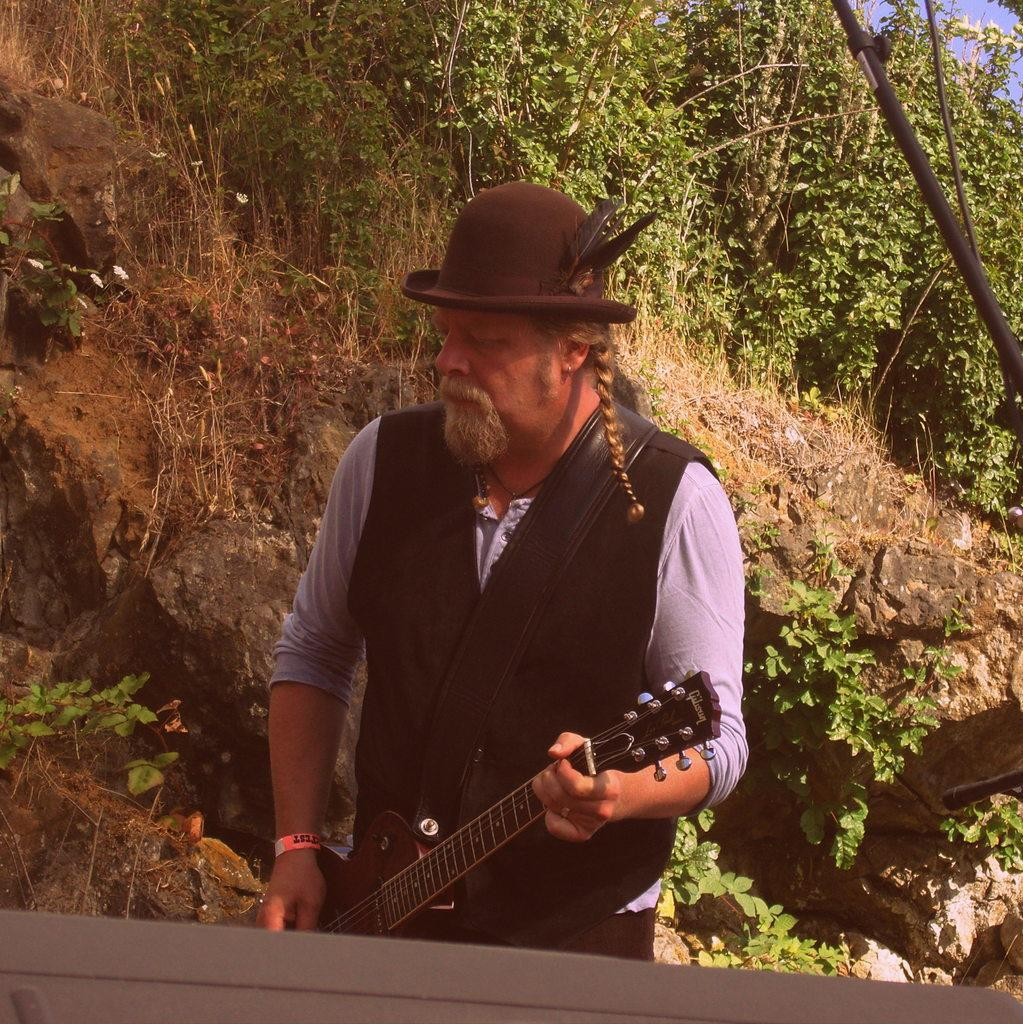What is the man in the image doing? The man is playing a guitar in the image. What is the man wearing on his upper body? The man is wearing a black jacket. What type of headwear is the man wearing? The man is wearing a cap. What can be seen on the cap? There are feathers on the cap. What can be seen in the background of the image? There are many trees and rocks in the background of the image. How does the man push the boot off his foot in the image? There is no boot or action of pushing in the image; the man is playing a guitar while wearing a cap with feathers. 